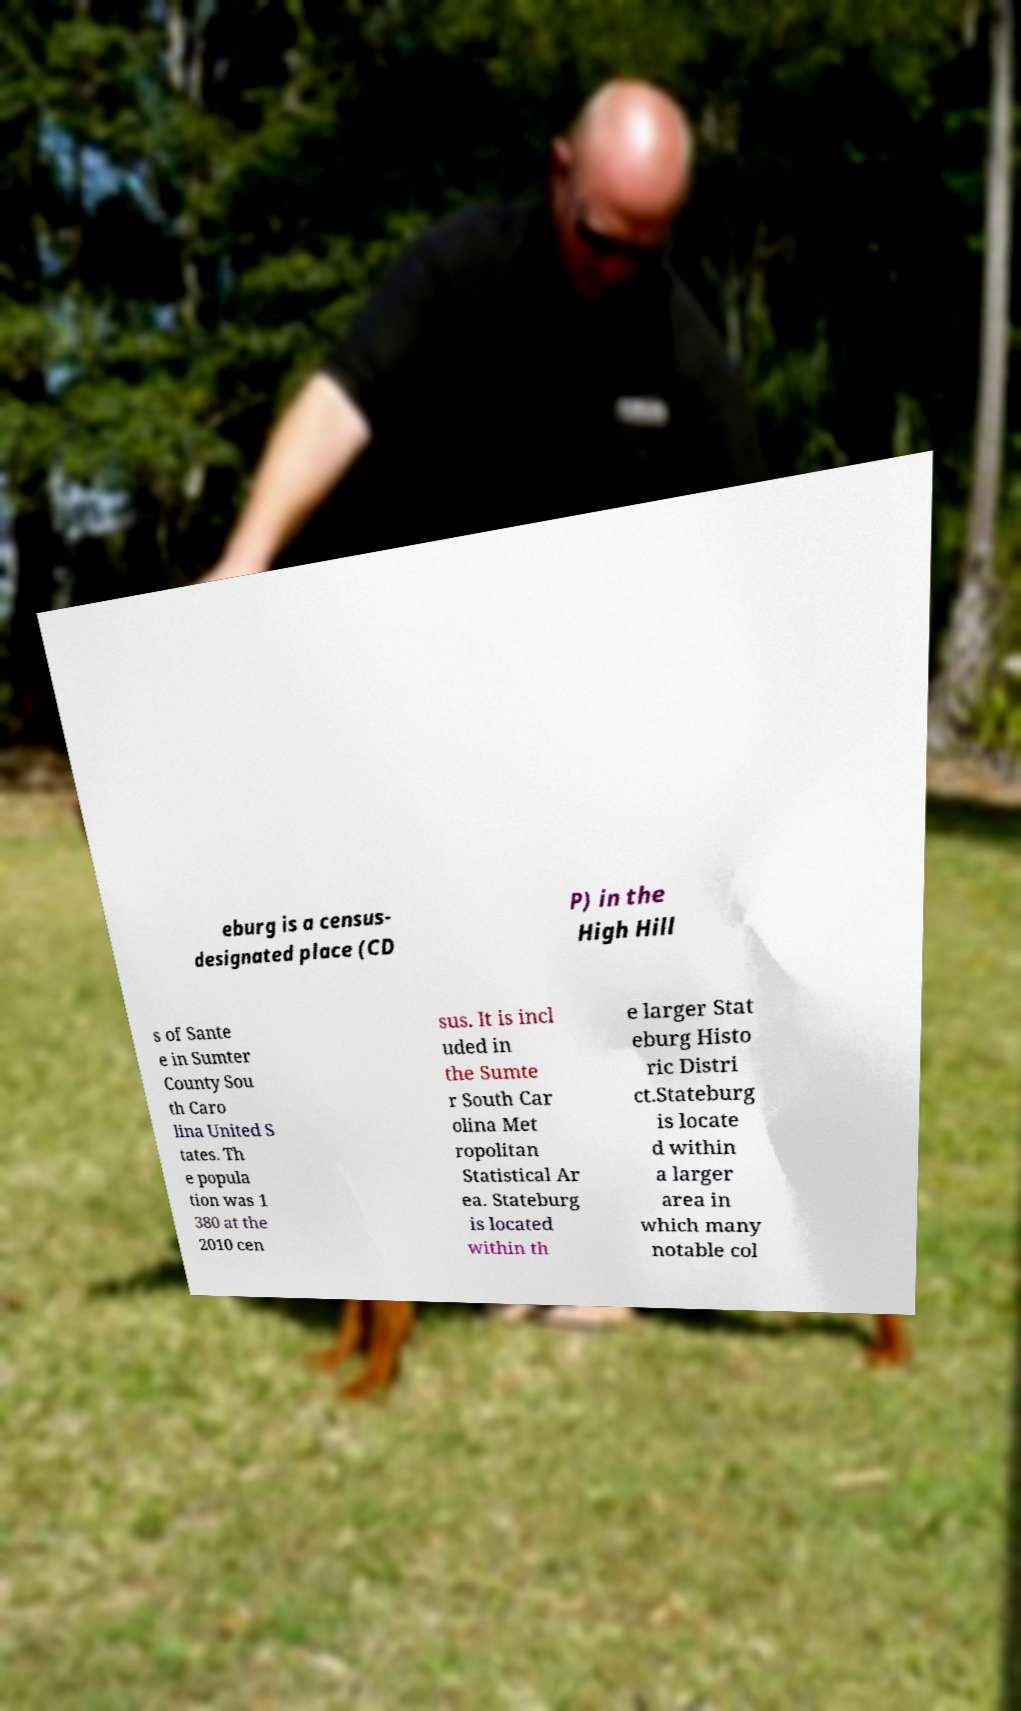I need the written content from this picture converted into text. Can you do that? eburg is a census- designated place (CD P) in the High Hill s of Sante e in Sumter County Sou th Caro lina United S tates. Th e popula tion was 1 380 at the 2010 cen sus. It is incl uded in the Sumte r South Car olina Met ropolitan Statistical Ar ea. Stateburg is located within th e larger Stat eburg Histo ric Distri ct.Stateburg is locate d within a larger area in which many notable col 